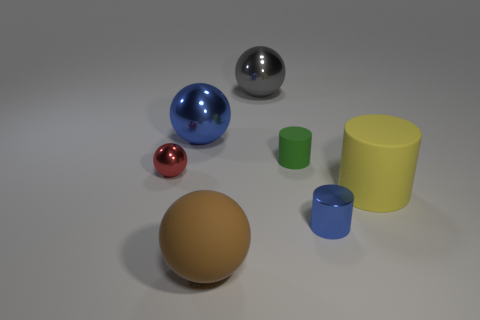Add 2 cylinders. How many objects exist? 9 Subtract all metal spheres. How many spheres are left? 1 Subtract all cylinders. How many objects are left? 4 Subtract 2 cylinders. How many cylinders are left? 1 Subtract all green cylinders. How many cylinders are left? 2 Subtract 0 cyan cylinders. How many objects are left? 7 Subtract all blue balls. Subtract all purple cylinders. How many balls are left? 3 Subtract all tiny purple cubes. Subtract all shiny cylinders. How many objects are left? 6 Add 4 big spheres. How many big spheres are left? 7 Add 1 yellow cylinders. How many yellow cylinders exist? 2 